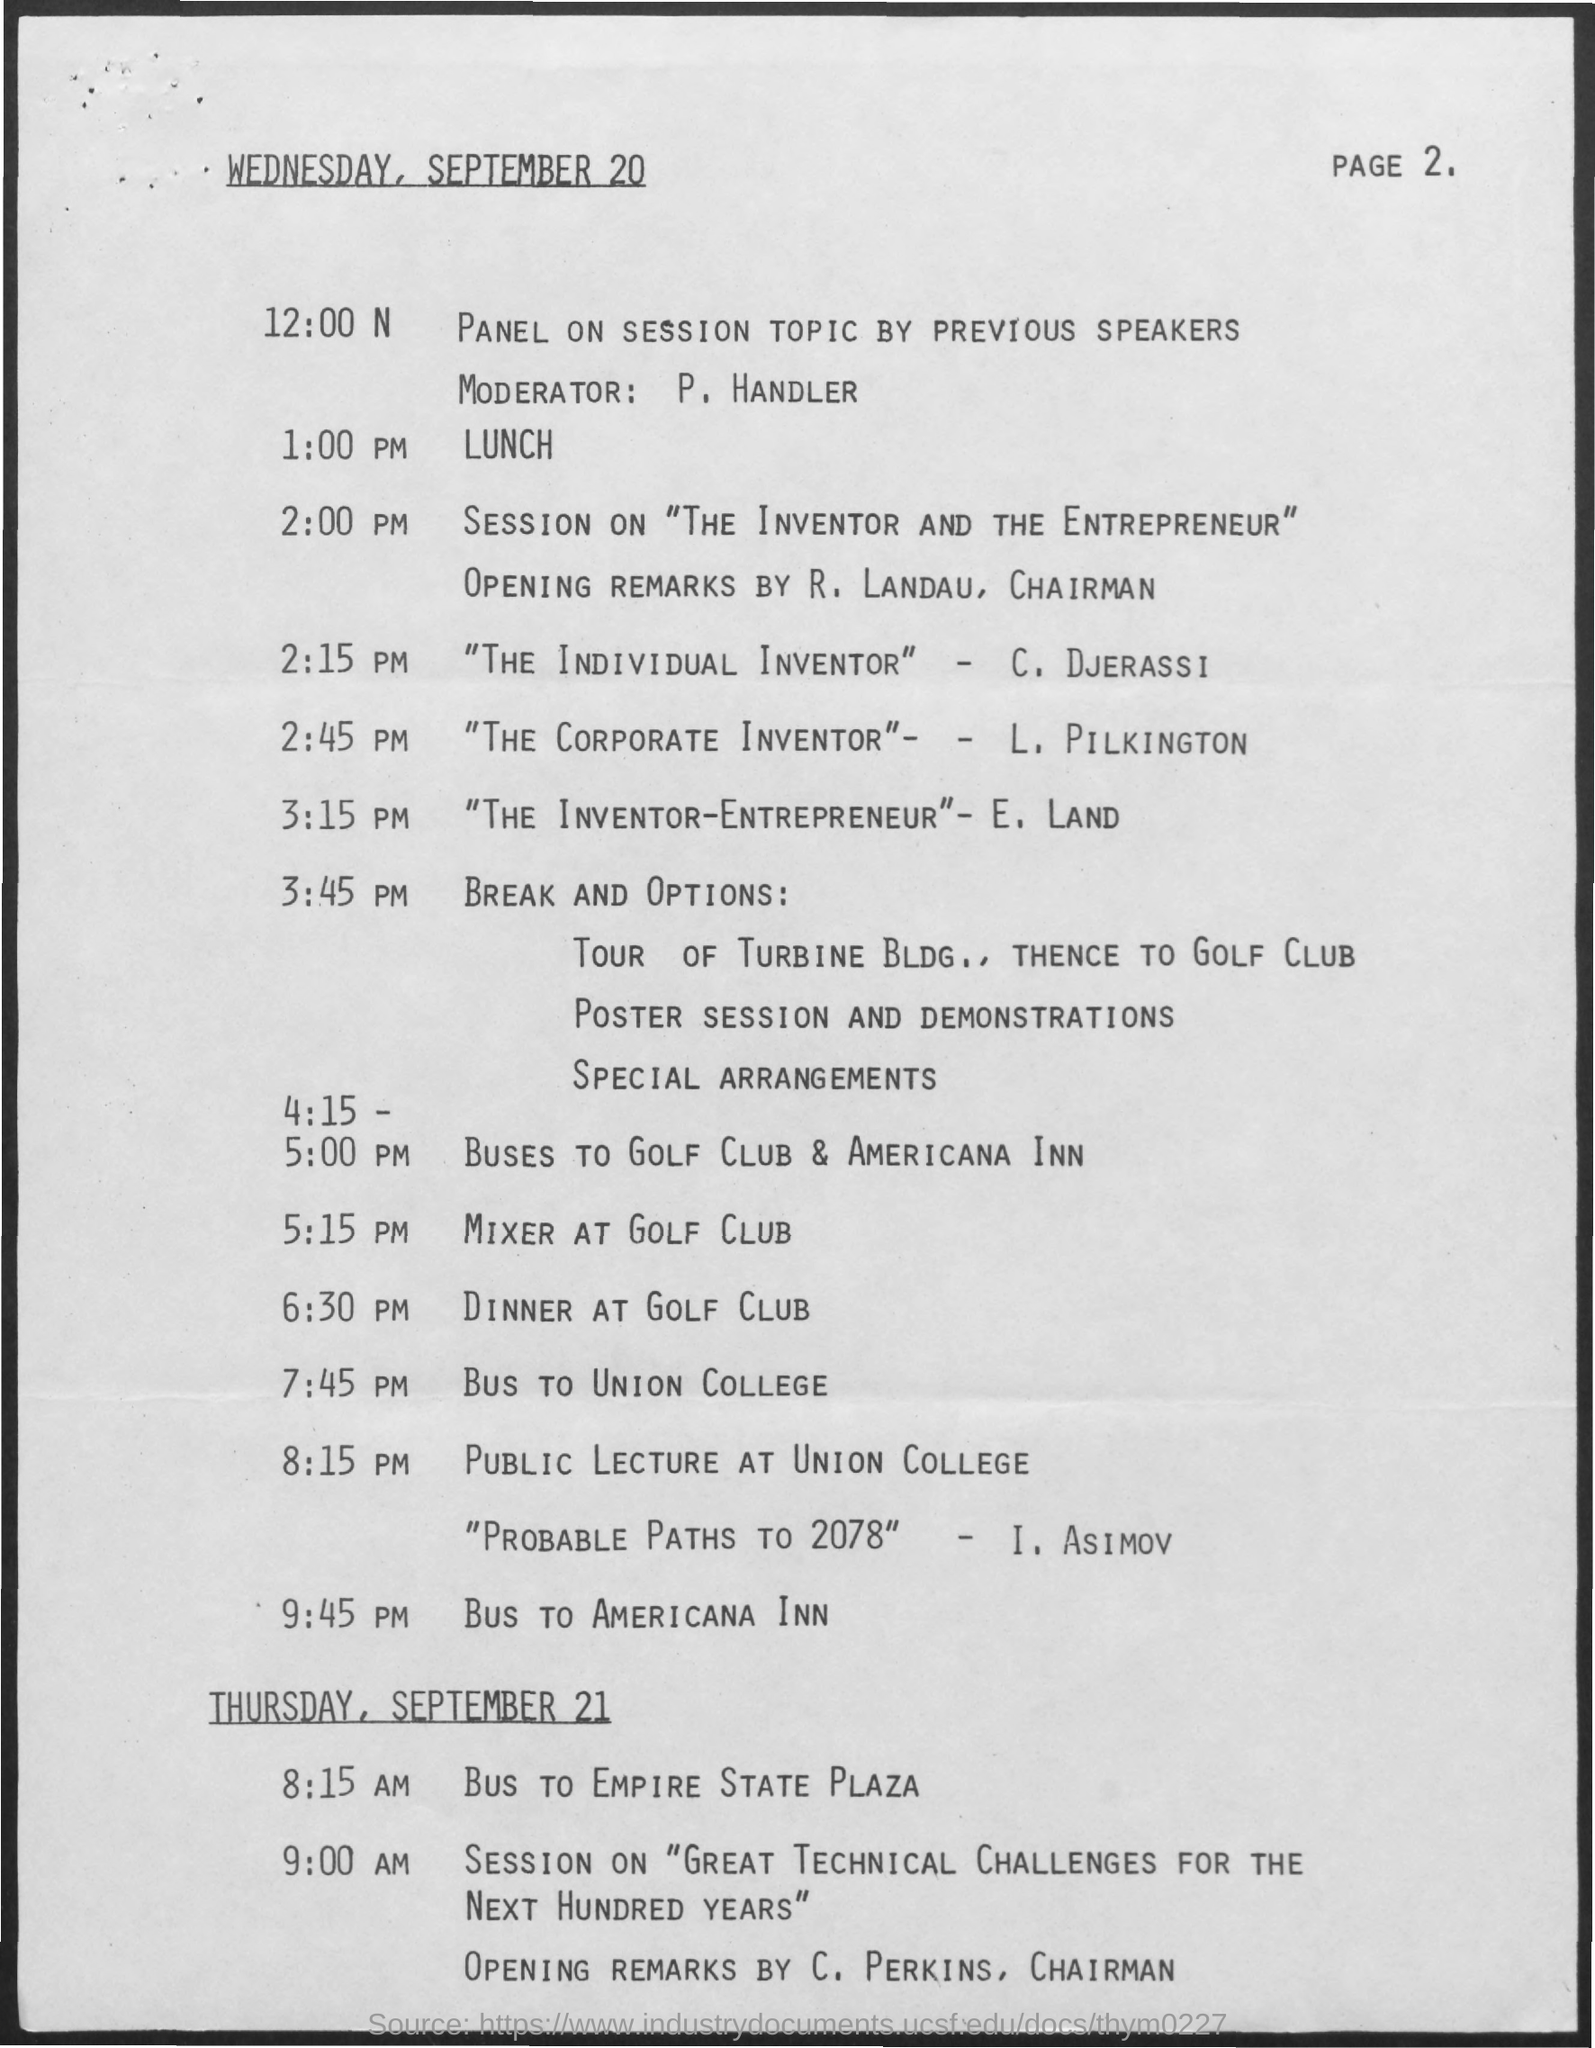Indicate a few pertinent items in this graphic. The date mentioned at the top of this document is Wednesday, September 20. 